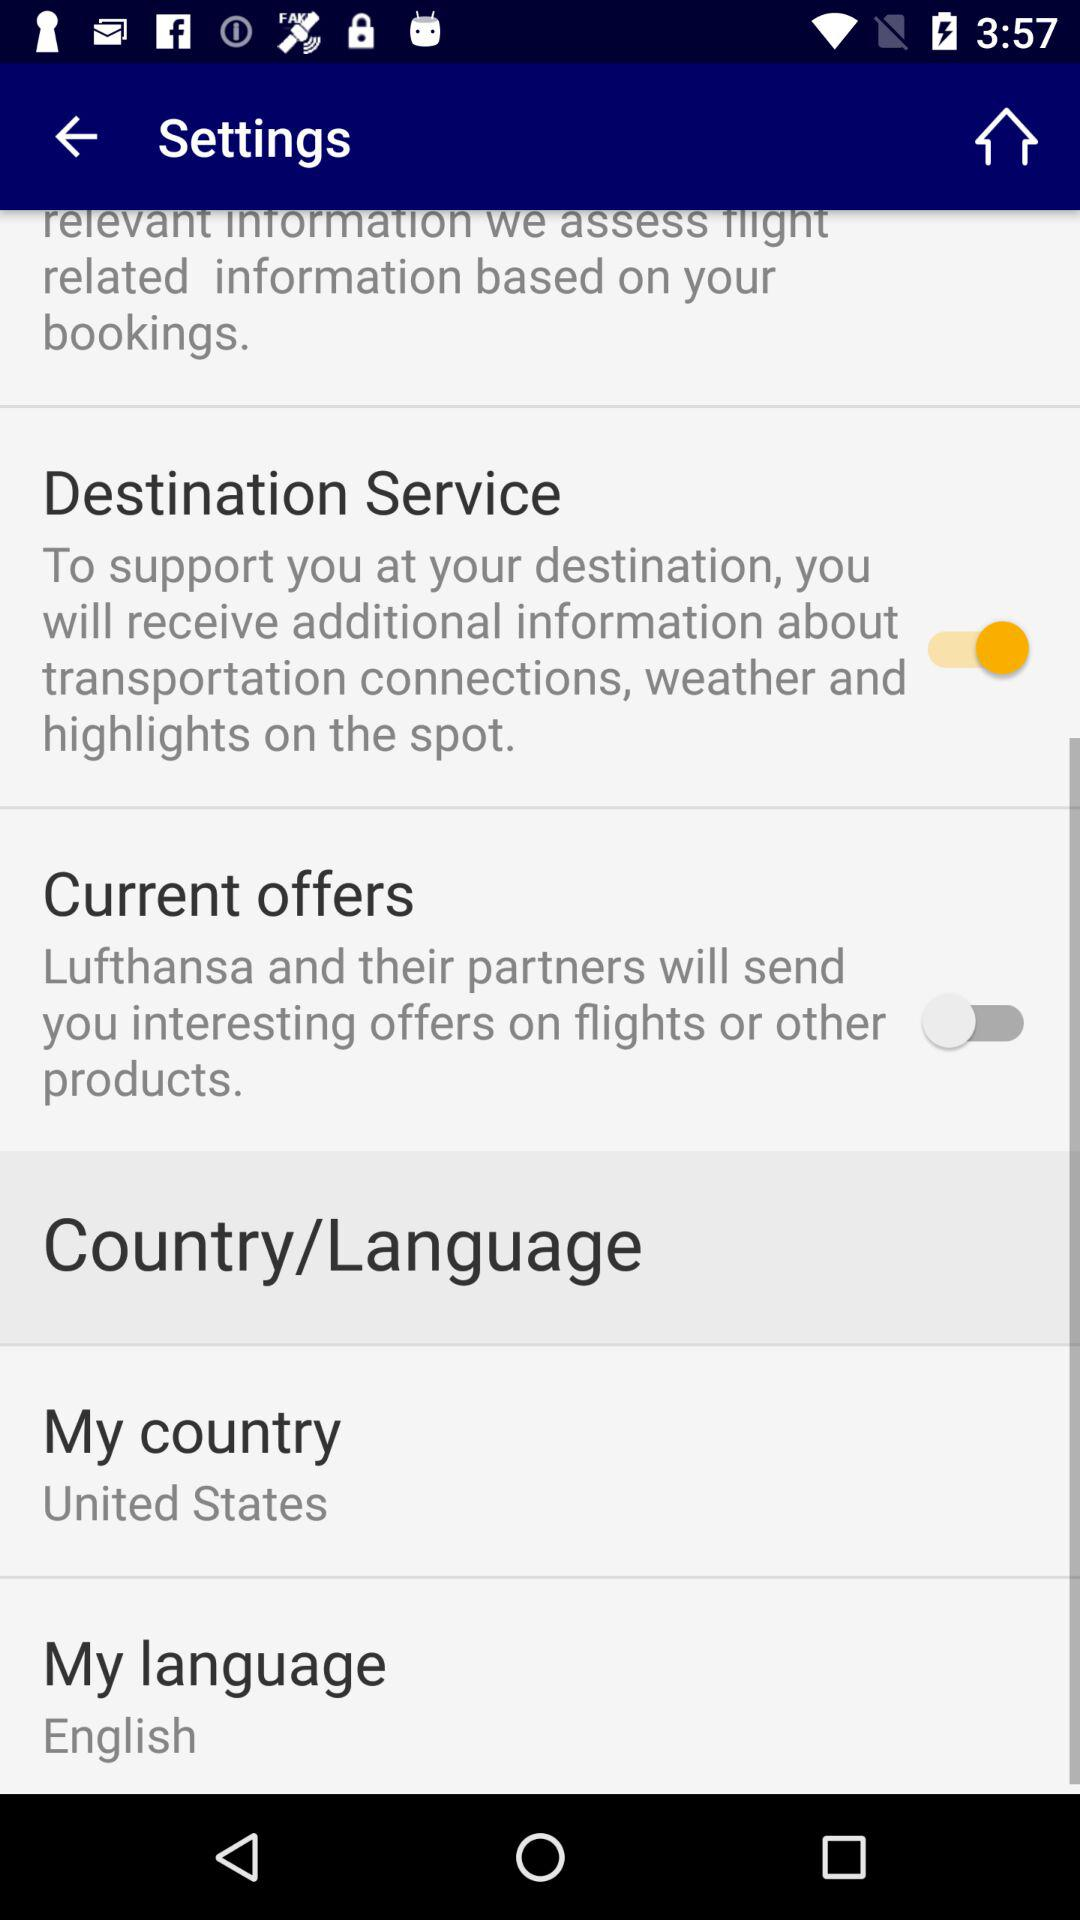What is the status of "Destination Service'? The status is on. 